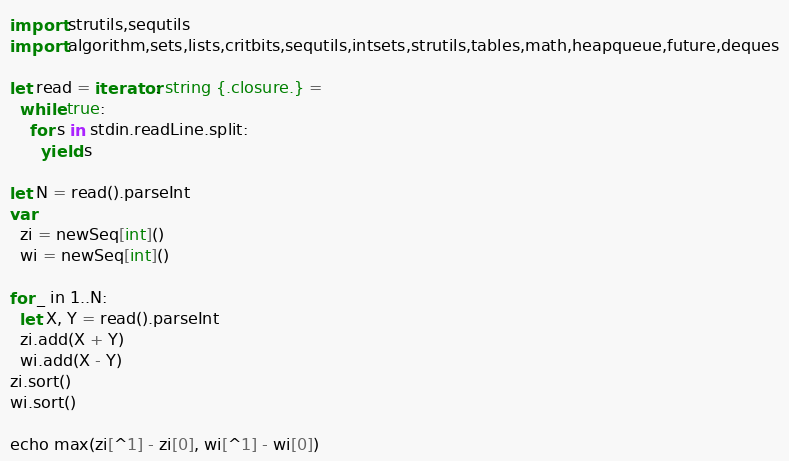<code> <loc_0><loc_0><loc_500><loc_500><_Nim_>import strutils,sequtils
import algorithm,sets,lists,critbits,sequtils,intsets,strutils,tables,math,heapqueue,future,deques

let read = iterator: string {.closure.} =
  while true:
    for s in stdin.readLine.split:
      yield s

let N = read().parseInt
var
  zi = newSeq[int]()
  wi = newSeq[int]()

for _ in 1..N:
  let X, Y = read().parseInt
  zi.add(X + Y)
  wi.add(X - Y)
zi.sort()
wi.sort()

echo max(zi[^1] - zi[0], wi[^1] - wi[0])
</code> 